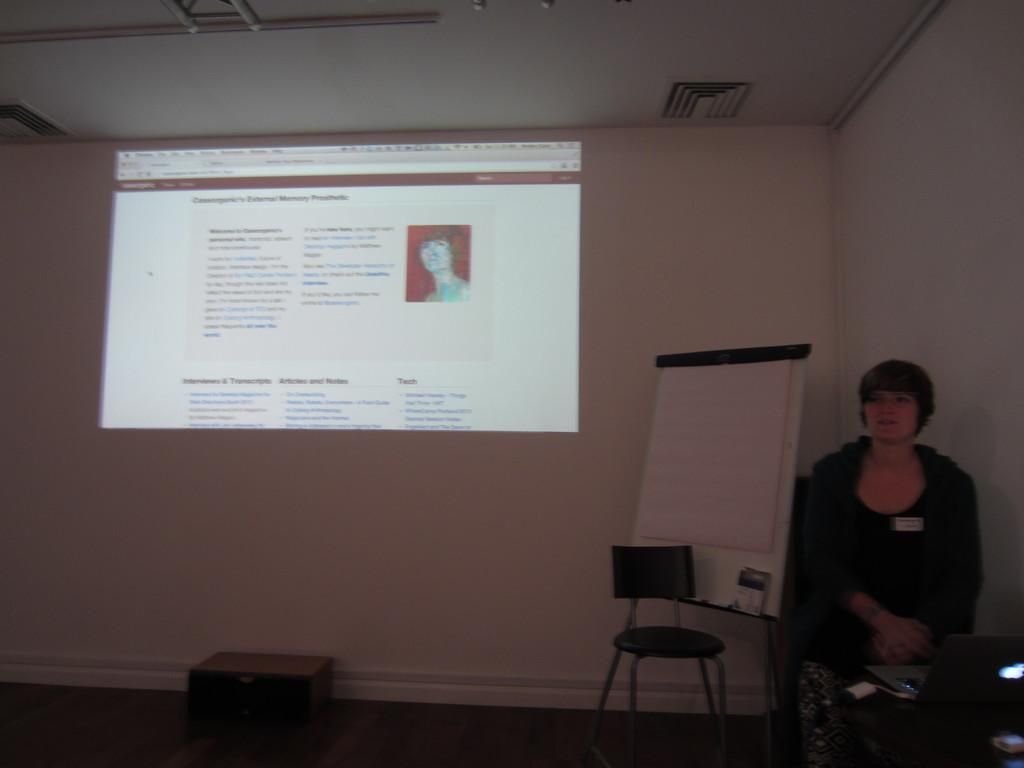Who is the main subject in the image? There is a lady in the image. What is the lady doing in the image? The lady is sitting on a chair in the image. What can be seen on the wall in the image? There is a screen on the wall in the image. What type of lumber is stacked behind the lady in the image? There is no lumber present in the image; it only features the lady sitting on a chair and a screen on the wall. 